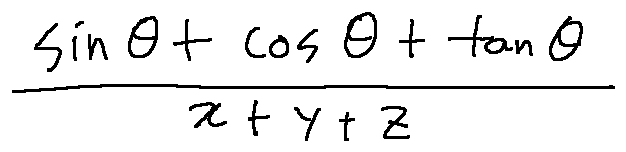Convert formula to latex. <formula><loc_0><loc_0><loc_500><loc_500>\frac { \sin \theta + \cos \theta + \tan \theta } { x + y + z }</formula> 